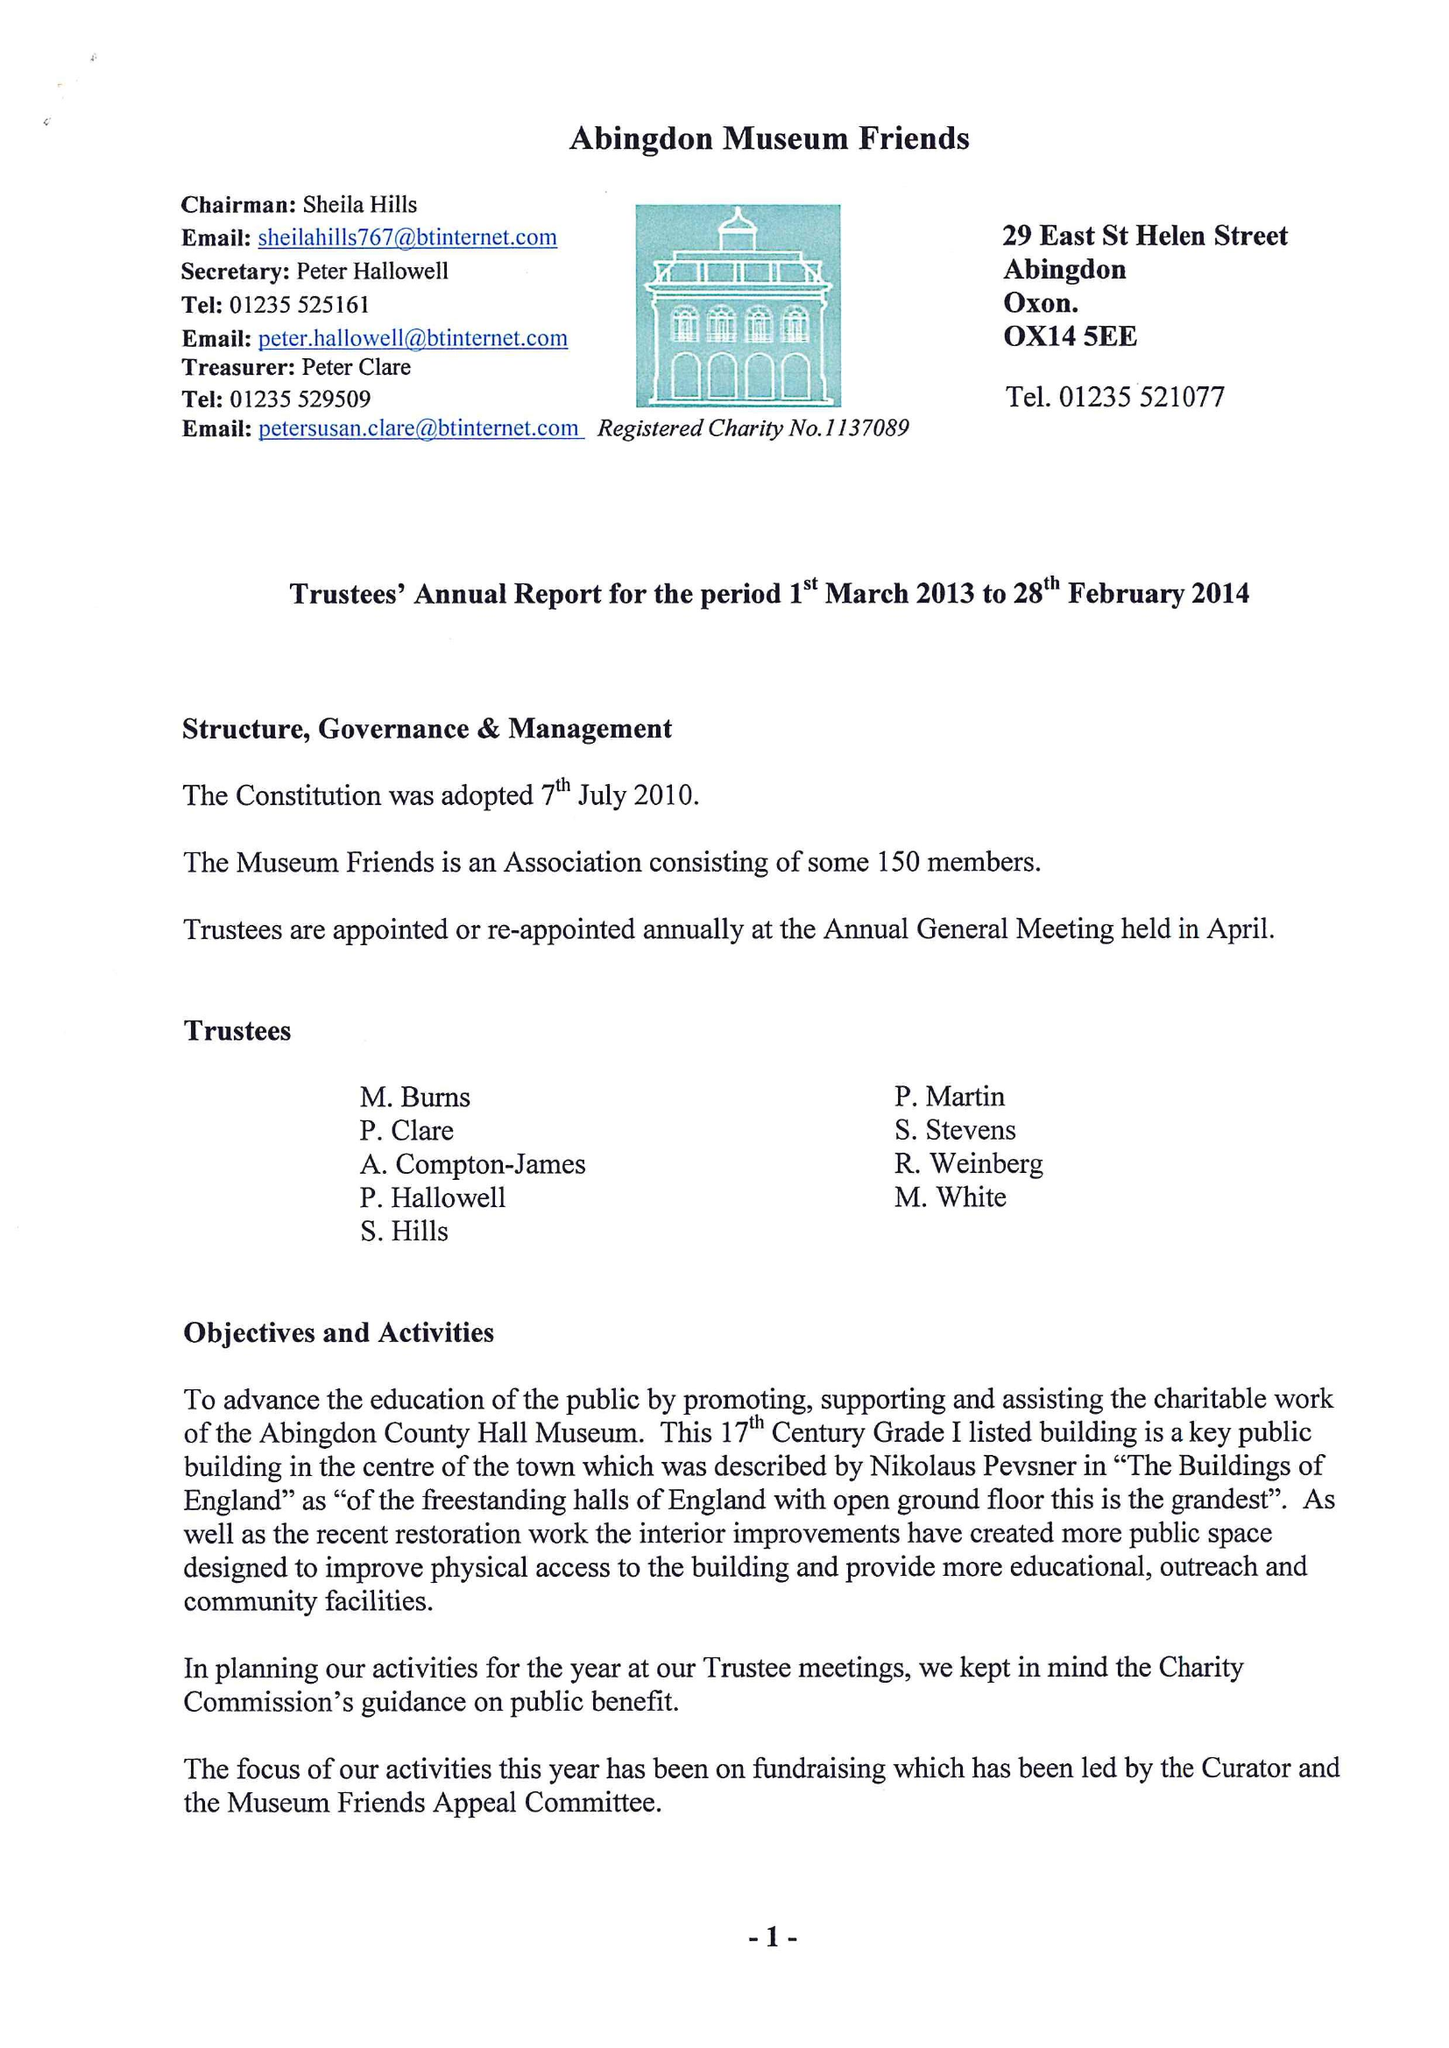What is the value for the charity_number?
Answer the question using a single word or phrase. 1137089 